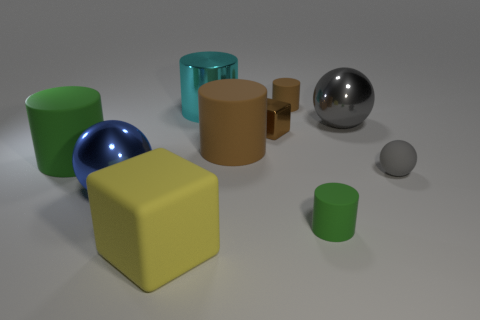Subtract 2 cylinders. How many cylinders are left? 3 Subtract all blocks. How many objects are left? 8 Add 7 large rubber cubes. How many large rubber cubes exist? 8 Subtract 0 green blocks. How many objects are left? 10 Subtract all tiny green matte objects. Subtract all cylinders. How many objects are left? 4 Add 3 matte things. How many matte things are left? 9 